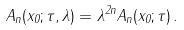Convert formula to latex. <formula><loc_0><loc_0><loc_500><loc_500>A _ { n } ( x _ { 0 } ; \tau , \lambda ) = \lambda ^ { 2 n } A _ { n } ( x _ { 0 } ; \tau ) \, .</formula> 